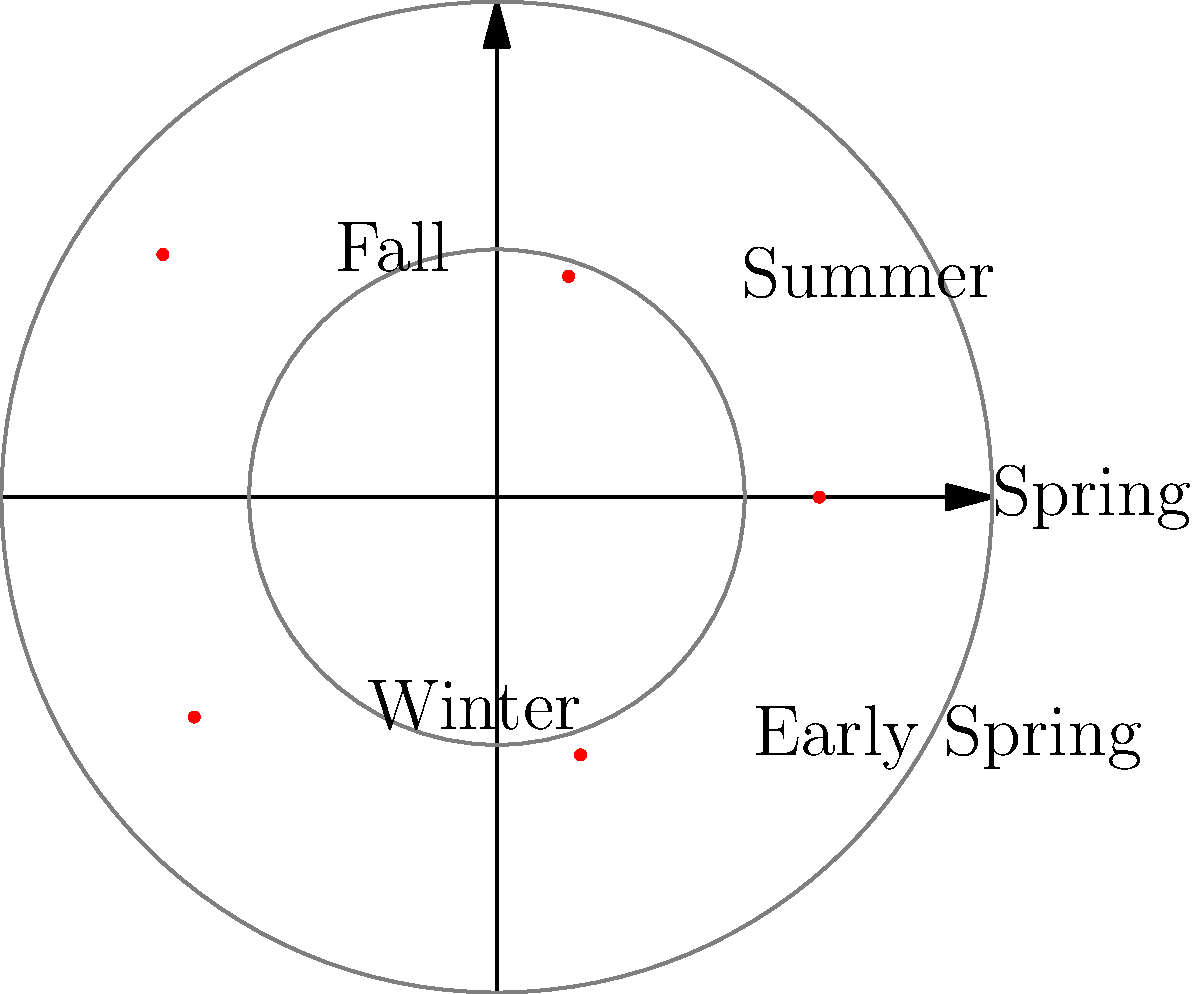The polar plot shows coffee bean yields (in tons per hectare) for different seasons. Which season had the highest yield, and what was the approximate yield? To determine the season with the highest yield and its approximate value, we need to follow these steps:

1. Observe the polar plot, where the distance from the center represents the yield.
2. Identify the point farthest from the center, which represents the highest yield.
3. Read the label associated with this point to determine the season.
4. Estimate the yield by comparing the point's distance to the concentric circles.

Looking at the plot:

1. The points represent yields for Spring, Summer, Fall, Winter, and Early Spring.
2. The point farthest from the center is in the upper-right quadrant.
3. This point is labeled "Fall".
4. The outer circle likely represents 3 tons per hectare, and the inner circle 1.5 tons per hectare.
5. The Fall point is slightly beyond the outer circle, so we can estimate it to be approximately 3.2 tons per hectare.

Therefore, Fall had the highest yield at approximately 3.2 tons per hectare.
Answer: Fall, 3.2 tons/hectare 